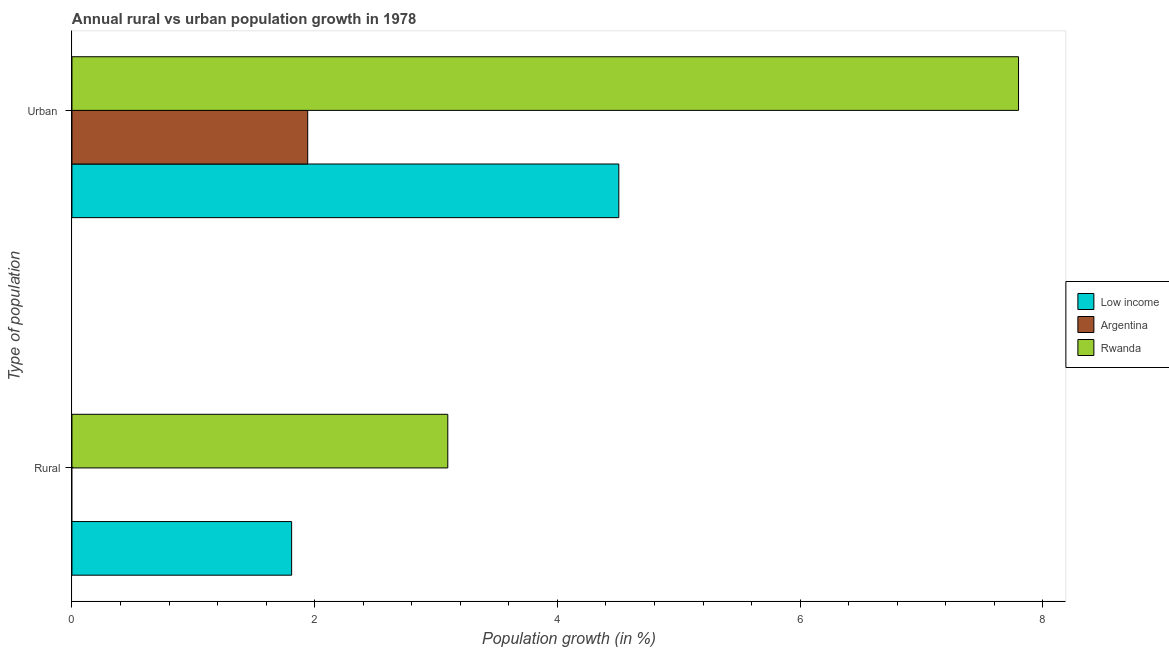How many groups of bars are there?
Provide a succinct answer. 2. Are the number of bars per tick equal to the number of legend labels?
Your response must be concise. No. Are the number of bars on each tick of the Y-axis equal?
Give a very brief answer. No. How many bars are there on the 1st tick from the bottom?
Your answer should be compact. 2. What is the label of the 2nd group of bars from the top?
Your answer should be very brief. Rural. What is the rural population growth in Rwanda?
Make the answer very short. 3.1. Across all countries, what is the maximum urban population growth?
Your answer should be compact. 7.8. Across all countries, what is the minimum urban population growth?
Offer a very short reply. 1.94. In which country was the urban population growth maximum?
Give a very brief answer. Rwanda. What is the total urban population growth in the graph?
Provide a short and direct response. 14.25. What is the difference between the urban population growth in Rwanda and that in Argentina?
Your response must be concise. 5.86. What is the difference between the urban population growth in Low income and the rural population growth in Argentina?
Your answer should be very brief. 4.51. What is the average rural population growth per country?
Your answer should be very brief. 1.64. What is the difference between the urban population growth and rural population growth in Low income?
Provide a short and direct response. 2.7. What is the ratio of the urban population growth in Rwanda to that in Low income?
Ensure brevity in your answer.  1.73. In how many countries, is the urban population growth greater than the average urban population growth taken over all countries?
Offer a terse response. 1. How many countries are there in the graph?
Provide a short and direct response. 3. What is the difference between two consecutive major ticks on the X-axis?
Provide a succinct answer. 2. Does the graph contain any zero values?
Offer a terse response. Yes. Does the graph contain grids?
Provide a short and direct response. No. Where does the legend appear in the graph?
Your answer should be compact. Center right. How many legend labels are there?
Your response must be concise. 3. What is the title of the graph?
Your answer should be very brief. Annual rural vs urban population growth in 1978. Does "Belize" appear as one of the legend labels in the graph?
Give a very brief answer. No. What is the label or title of the X-axis?
Give a very brief answer. Population growth (in %). What is the label or title of the Y-axis?
Ensure brevity in your answer.  Type of population. What is the Population growth (in %) of Low income in Rural?
Ensure brevity in your answer.  1.81. What is the Population growth (in %) of Rwanda in Rural?
Your response must be concise. 3.1. What is the Population growth (in %) of Low income in Urban ?
Offer a terse response. 4.51. What is the Population growth (in %) of Argentina in Urban ?
Your answer should be compact. 1.94. What is the Population growth (in %) of Rwanda in Urban ?
Provide a short and direct response. 7.8. Across all Type of population, what is the maximum Population growth (in %) in Low income?
Provide a succinct answer. 4.51. Across all Type of population, what is the maximum Population growth (in %) of Argentina?
Ensure brevity in your answer.  1.94. Across all Type of population, what is the maximum Population growth (in %) in Rwanda?
Give a very brief answer. 7.8. Across all Type of population, what is the minimum Population growth (in %) in Low income?
Provide a succinct answer. 1.81. Across all Type of population, what is the minimum Population growth (in %) of Argentina?
Provide a succinct answer. 0. Across all Type of population, what is the minimum Population growth (in %) in Rwanda?
Ensure brevity in your answer.  3.1. What is the total Population growth (in %) in Low income in the graph?
Make the answer very short. 6.32. What is the total Population growth (in %) in Argentina in the graph?
Keep it short and to the point. 1.94. What is the total Population growth (in %) in Rwanda in the graph?
Provide a succinct answer. 10.9. What is the difference between the Population growth (in %) of Low income in Rural and that in Urban ?
Give a very brief answer. -2.7. What is the difference between the Population growth (in %) in Rwanda in Rural and that in Urban ?
Your answer should be very brief. -4.7. What is the difference between the Population growth (in %) of Low income in Rural and the Population growth (in %) of Argentina in Urban ?
Offer a very short reply. -0.13. What is the difference between the Population growth (in %) in Low income in Rural and the Population growth (in %) in Rwanda in Urban ?
Your answer should be compact. -5.99. What is the average Population growth (in %) in Low income per Type of population?
Your answer should be compact. 3.16. What is the average Population growth (in %) in Argentina per Type of population?
Offer a very short reply. 0.97. What is the average Population growth (in %) of Rwanda per Type of population?
Provide a short and direct response. 5.45. What is the difference between the Population growth (in %) of Low income and Population growth (in %) of Rwanda in Rural?
Offer a very short reply. -1.29. What is the difference between the Population growth (in %) of Low income and Population growth (in %) of Argentina in Urban ?
Your answer should be compact. 2.56. What is the difference between the Population growth (in %) of Low income and Population growth (in %) of Rwanda in Urban ?
Provide a short and direct response. -3.29. What is the difference between the Population growth (in %) in Argentina and Population growth (in %) in Rwanda in Urban ?
Your answer should be very brief. -5.86. What is the ratio of the Population growth (in %) in Low income in Rural to that in Urban ?
Offer a terse response. 0.4. What is the ratio of the Population growth (in %) in Rwanda in Rural to that in Urban ?
Ensure brevity in your answer.  0.4. What is the difference between the highest and the second highest Population growth (in %) in Low income?
Provide a short and direct response. 2.7. What is the difference between the highest and the second highest Population growth (in %) in Rwanda?
Your answer should be compact. 4.7. What is the difference between the highest and the lowest Population growth (in %) in Low income?
Your answer should be compact. 2.7. What is the difference between the highest and the lowest Population growth (in %) of Argentina?
Provide a short and direct response. 1.94. What is the difference between the highest and the lowest Population growth (in %) in Rwanda?
Give a very brief answer. 4.7. 